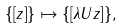<formula> <loc_0><loc_0><loc_500><loc_500>\{ [ z ] \} \mapsto \left \{ [ \lambda U z \right ] \} ,</formula> 